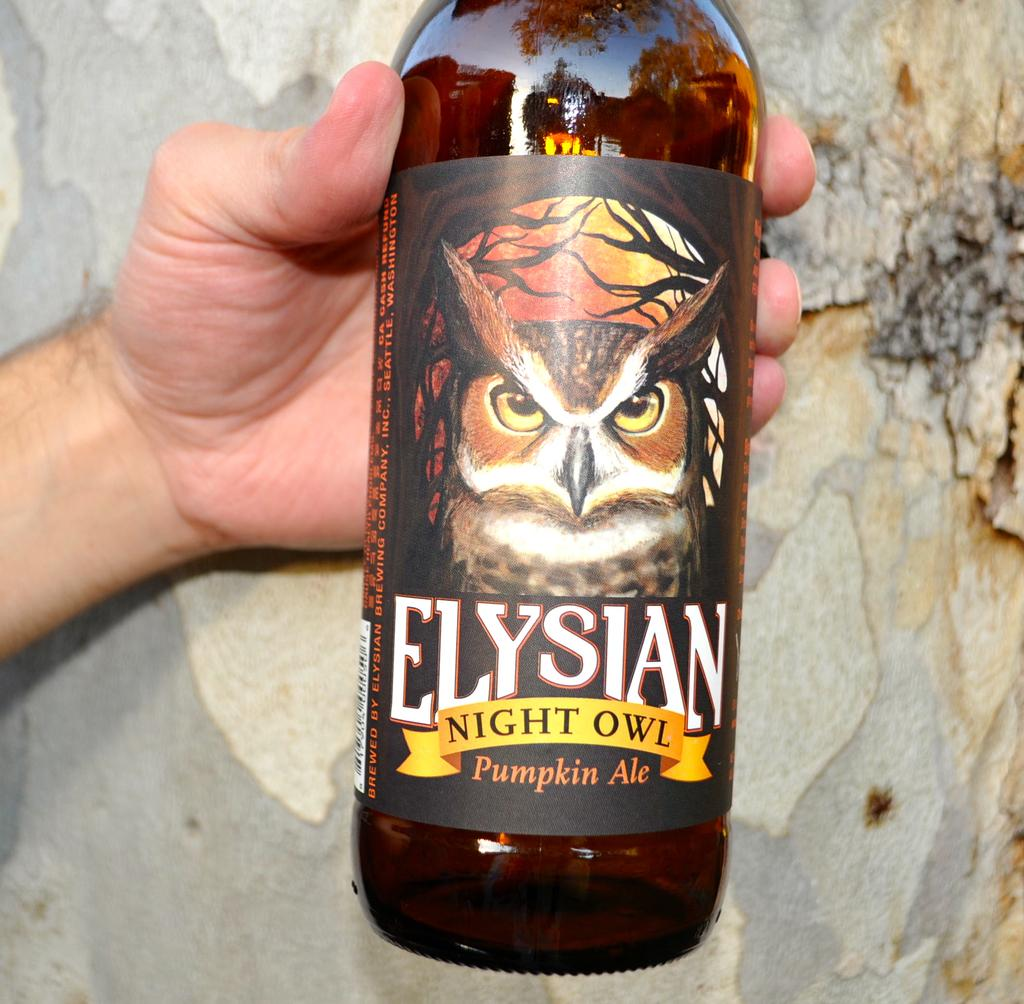<image>
Describe the image concisely. A bottle of Elysian Night Owl Pumpkin Ale being held in a hand. 